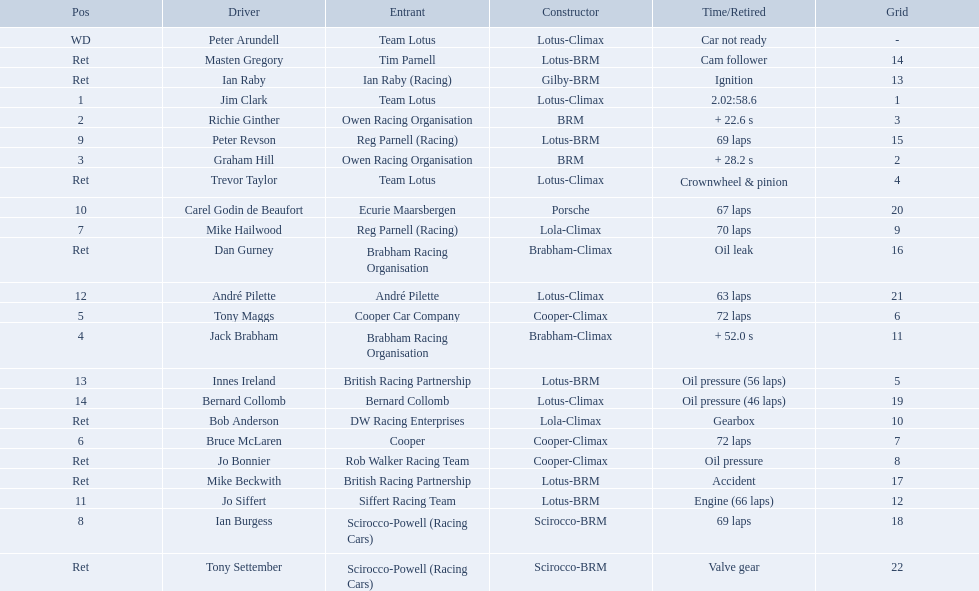Who all drive cars that were constructed bur climax? Jim Clark, Jack Brabham, Tony Maggs, Bruce McLaren, Mike Hailwood, André Pilette, Bernard Collomb, Dan Gurney, Trevor Taylor, Jo Bonnier, Bob Anderson, Peter Arundell. Which driver's climax constructed cars started in the top 10 on the grid? Jim Clark, Tony Maggs, Bruce McLaren, Mike Hailwood, Jo Bonnier, Bob Anderson. Of the top 10 starting climax constructed drivers, which ones did not finish the race? Jo Bonnier, Bob Anderson. What was the failure that was engine related that took out the driver of the climax constructed car that did not finish even though it started in the top 10? Oil pressure. Who were the drivers in the the 1963 international gold cup? Jim Clark, Richie Ginther, Graham Hill, Jack Brabham, Tony Maggs, Bruce McLaren, Mike Hailwood, Ian Burgess, Peter Revson, Carel Godin de Beaufort, Jo Siffert, André Pilette, Innes Ireland, Bernard Collomb, Ian Raby, Dan Gurney, Mike Beckwith, Masten Gregory, Trevor Taylor, Jo Bonnier, Tony Settember, Bob Anderson, Peter Arundell. Which drivers drove a cooper-climax car? Tony Maggs, Bruce McLaren, Jo Bonnier. What did these drivers place? 5, 6, Ret. What was the best placing position? 5. Who was the driver with this placing? Tony Maggs. Who are all the drivers? Jim Clark, Richie Ginther, Graham Hill, Jack Brabham, Tony Maggs, Bruce McLaren, Mike Hailwood, Ian Burgess, Peter Revson, Carel Godin de Beaufort, Jo Siffert, André Pilette, Innes Ireland, Bernard Collomb, Ian Raby, Dan Gurney, Mike Beckwith, Masten Gregory, Trevor Taylor, Jo Bonnier, Tony Settember, Bob Anderson, Peter Arundell. What were their positions? 1, 2, 3, 4, 5, 6, 7, 8, 9, 10, 11, 12, 13, 14, Ret, Ret, Ret, Ret, Ret, Ret, Ret, Ret, WD. What are all the constructor names? Lotus-Climax, BRM, BRM, Brabham-Climax, Cooper-Climax, Cooper-Climax, Lola-Climax, Scirocco-BRM, Lotus-BRM, Porsche, Lotus-BRM, Lotus-Climax, Lotus-BRM, Lotus-Climax, Gilby-BRM, Brabham-Climax, Lotus-BRM, Lotus-BRM, Lotus-Climax, Cooper-Climax, Scirocco-BRM, Lola-Climax, Lotus-Climax. And which drivers drove a cooper-climax? Tony Maggs, Bruce McLaren. Between those tow, who was positioned higher? Tony Maggs. 